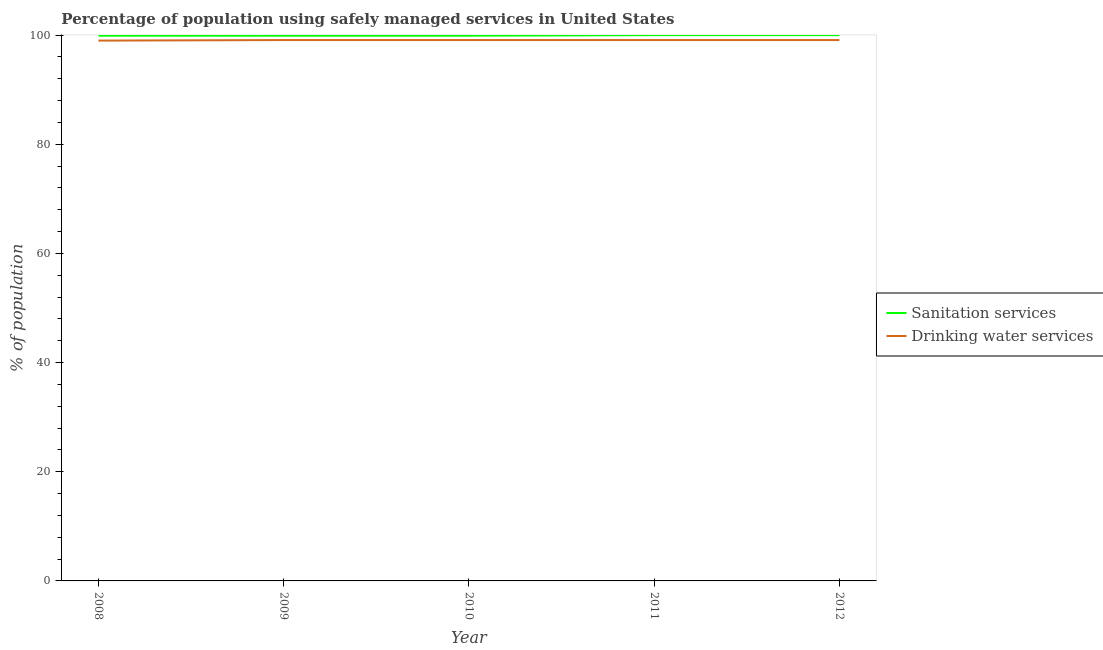How many different coloured lines are there?
Your response must be concise. 2. Does the line corresponding to percentage of population who used sanitation services intersect with the line corresponding to percentage of population who used drinking water services?
Provide a short and direct response. No. Is the number of lines equal to the number of legend labels?
Offer a very short reply. Yes. What is the percentage of population who used drinking water services in 2012?
Your answer should be compact. 99.1. Across all years, what is the maximum percentage of population who used drinking water services?
Make the answer very short. 99.1. Across all years, what is the minimum percentage of population who used sanitation services?
Offer a very short reply. 99.9. What is the total percentage of population who used sanitation services in the graph?
Give a very brief answer. 499.7. What is the difference between the percentage of population who used drinking water services in 2012 and the percentage of population who used sanitation services in 2009?
Provide a succinct answer. -0.8. What is the average percentage of population who used drinking water services per year?
Give a very brief answer. 99.08. In the year 2012, what is the difference between the percentage of population who used drinking water services and percentage of population who used sanitation services?
Your response must be concise. -0.9. In how many years, is the percentage of population who used drinking water services greater than 96 %?
Your answer should be very brief. 5. What is the ratio of the percentage of population who used sanitation services in 2008 to that in 2011?
Keep it short and to the point. 1. Is the percentage of population who used sanitation services in 2008 less than that in 2009?
Your answer should be compact. No. What is the difference between the highest and the lowest percentage of population who used sanitation services?
Ensure brevity in your answer.  0.1. In how many years, is the percentage of population who used sanitation services greater than the average percentage of population who used sanitation services taken over all years?
Provide a short and direct response. 2. Is the sum of the percentage of population who used drinking water services in 2008 and 2011 greater than the maximum percentage of population who used sanitation services across all years?
Make the answer very short. Yes. Is the percentage of population who used sanitation services strictly greater than the percentage of population who used drinking water services over the years?
Your response must be concise. Yes. Is the percentage of population who used drinking water services strictly less than the percentage of population who used sanitation services over the years?
Offer a very short reply. Yes. How many lines are there?
Your answer should be very brief. 2. Does the graph contain grids?
Ensure brevity in your answer.  No. Where does the legend appear in the graph?
Your answer should be compact. Center right. How are the legend labels stacked?
Provide a short and direct response. Vertical. What is the title of the graph?
Make the answer very short. Percentage of population using safely managed services in United States. What is the label or title of the Y-axis?
Give a very brief answer. % of population. What is the % of population of Sanitation services in 2008?
Your response must be concise. 99.9. What is the % of population of Sanitation services in 2009?
Offer a very short reply. 99.9. What is the % of population of Drinking water services in 2009?
Your answer should be very brief. 99.1. What is the % of population in Sanitation services in 2010?
Offer a terse response. 99.9. What is the % of population of Drinking water services in 2010?
Provide a short and direct response. 99.1. What is the % of population in Drinking water services in 2011?
Offer a terse response. 99.1. What is the % of population in Sanitation services in 2012?
Ensure brevity in your answer.  100. What is the % of population in Drinking water services in 2012?
Provide a succinct answer. 99.1. Across all years, what is the maximum % of population in Drinking water services?
Ensure brevity in your answer.  99.1. Across all years, what is the minimum % of population of Sanitation services?
Your response must be concise. 99.9. Across all years, what is the minimum % of population in Drinking water services?
Offer a terse response. 99. What is the total % of population in Sanitation services in the graph?
Your response must be concise. 499.7. What is the total % of population in Drinking water services in the graph?
Your response must be concise. 495.4. What is the difference between the % of population in Drinking water services in 2008 and that in 2010?
Your answer should be very brief. -0.1. What is the difference between the % of population in Sanitation services in 2008 and that in 2011?
Ensure brevity in your answer.  -0.1. What is the difference between the % of population in Sanitation services in 2008 and that in 2012?
Provide a succinct answer. -0.1. What is the difference between the % of population of Drinking water services in 2008 and that in 2012?
Your answer should be compact. -0.1. What is the difference between the % of population in Sanitation services in 2009 and that in 2010?
Offer a very short reply. 0. What is the difference between the % of population in Drinking water services in 2009 and that in 2010?
Provide a succinct answer. 0. What is the difference between the % of population in Drinking water services in 2009 and that in 2012?
Offer a very short reply. 0. What is the difference between the % of population in Drinking water services in 2010 and that in 2011?
Ensure brevity in your answer.  0. What is the difference between the % of population in Drinking water services in 2010 and that in 2012?
Provide a succinct answer. 0. What is the difference between the % of population in Sanitation services in 2008 and the % of population in Drinking water services in 2010?
Keep it short and to the point. 0.8. What is the difference between the % of population of Sanitation services in 2008 and the % of population of Drinking water services in 2012?
Give a very brief answer. 0.8. What is the difference between the % of population of Sanitation services in 2009 and the % of population of Drinking water services in 2010?
Offer a very short reply. 0.8. What is the difference between the % of population in Sanitation services in 2009 and the % of population in Drinking water services in 2012?
Your response must be concise. 0.8. What is the difference between the % of population in Sanitation services in 2010 and the % of population in Drinking water services in 2011?
Provide a succinct answer. 0.8. What is the difference between the % of population in Sanitation services in 2011 and the % of population in Drinking water services in 2012?
Offer a very short reply. 0.9. What is the average % of population of Sanitation services per year?
Your response must be concise. 99.94. What is the average % of population in Drinking water services per year?
Your answer should be very brief. 99.08. In the year 2008, what is the difference between the % of population of Sanitation services and % of population of Drinking water services?
Offer a terse response. 0.9. In the year 2009, what is the difference between the % of population in Sanitation services and % of population in Drinking water services?
Your answer should be compact. 0.8. In the year 2010, what is the difference between the % of population in Sanitation services and % of population in Drinking water services?
Keep it short and to the point. 0.8. In the year 2011, what is the difference between the % of population of Sanitation services and % of population of Drinking water services?
Offer a very short reply. 0.9. What is the ratio of the % of population of Sanitation services in 2008 to that in 2010?
Your answer should be very brief. 1. What is the ratio of the % of population of Drinking water services in 2008 to that in 2010?
Keep it short and to the point. 1. What is the ratio of the % of population of Sanitation services in 2008 to that in 2011?
Offer a very short reply. 1. What is the ratio of the % of population in Drinking water services in 2008 to that in 2011?
Keep it short and to the point. 1. What is the ratio of the % of population of Drinking water services in 2008 to that in 2012?
Make the answer very short. 1. What is the ratio of the % of population in Sanitation services in 2009 to that in 2010?
Provide a succinct answer. 1. What is the ratio of the % of population in Sanitation services in 2009 to that in 2011?
Ensure brevity in your answer.  1. What is the ratio of the % of population in Sanitation services in 2009 to that in 2012?
Make the answer very short. 1. What is the ratio of the % of population in Sanitation services in 2010 to that in 2011?
Your answer should be compact. 1. What is the ratio of the % of population of Drinking water services in 2010 to that in 2011?
Your answer should be compact. 1. What is the ratio of the % of population of Drinking water services in 2011 to that in 2012?
Make the answer very short. 1. What is the difference between the highest and the second highest % of population of Drinking water services?
Ensure brevity in your answer.  0. What is the difference between the highest and the lowest % of population in Sanitation services?
Make the answer very short. 0.1. What is the difference between the highest and the lowest % of population in Drinking water services?
Your answer should be very brief. 0.1. 